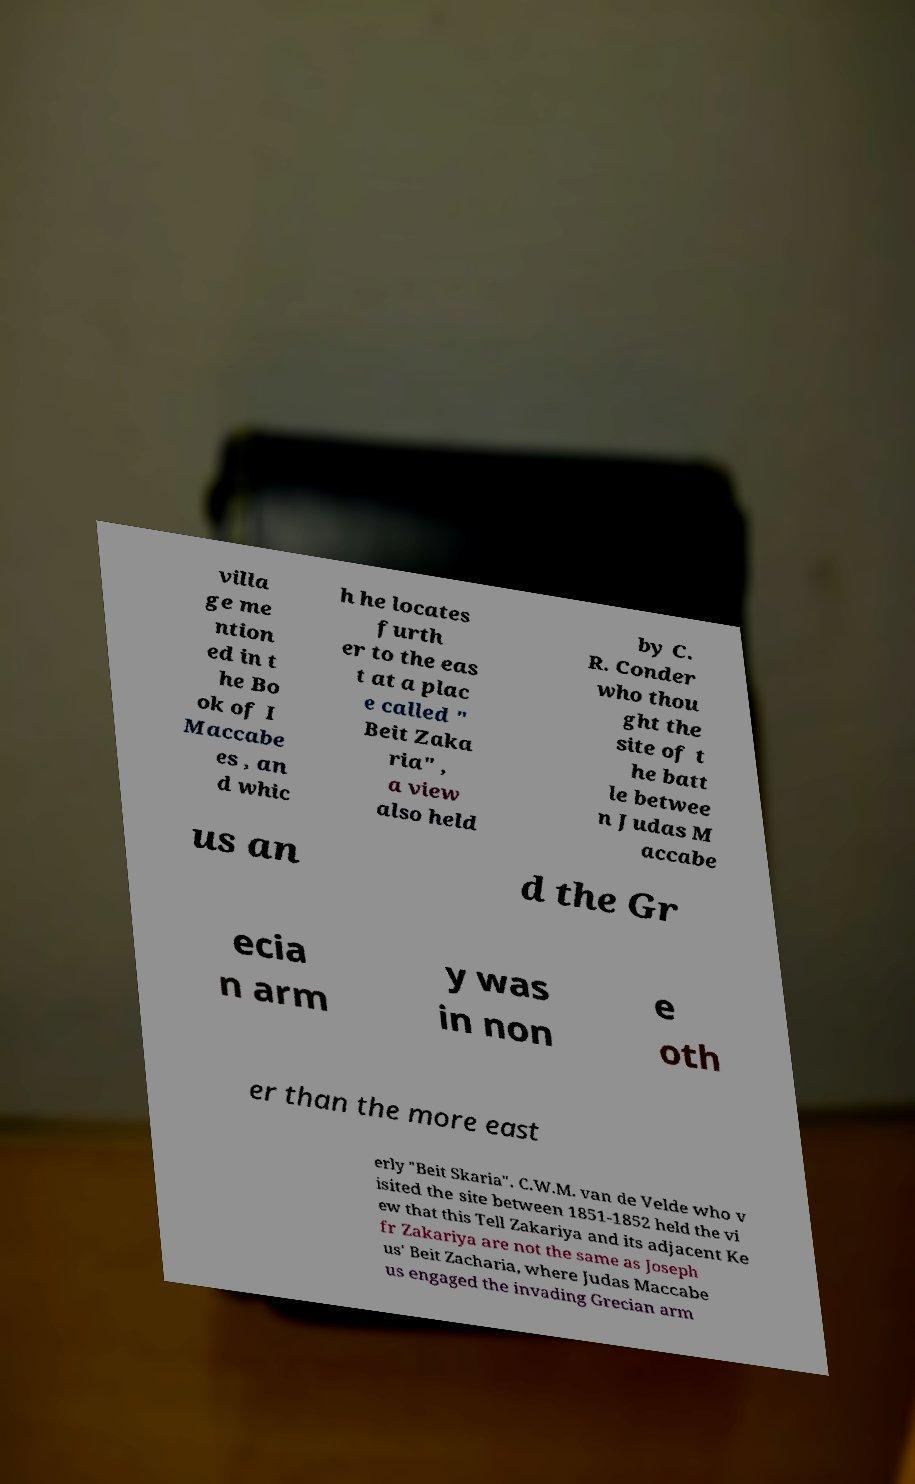There's text embedded in this image that I need extracted. Can you transcribe it verbatim? villa ge me ntion ed in t he Bo ok of I Maccabe es , an d whic h he locates furth er to the eas t at a plac e called " Beit Zaka ria" , a view also held by C. R. Conder who thou ght the site of t he batt le betwee n Judas M accabe us an d the Gr ecia n arm y was in non e oth er than the more east erly "Beit Skaria". C.W.M. van de Velde who v isited the site between 1851-1852 held the vi ew that this Tell Zakariya and its adjacent Ke fr Zakariya are not the same as Joseph us' Beit Zacharia, where Judas Maccabe us engaged the invading Grecian arm 